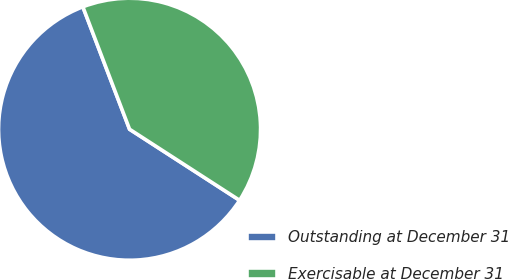Convert chart to OTSL. <chart><loc_0><loc_0><loc_500><loc_500><pie_chart><fcel>Outstanding at December 31<fcel>Exercisable at December 31<nl><fcel>60.07%<fcel>39.93%<nl></chart> 